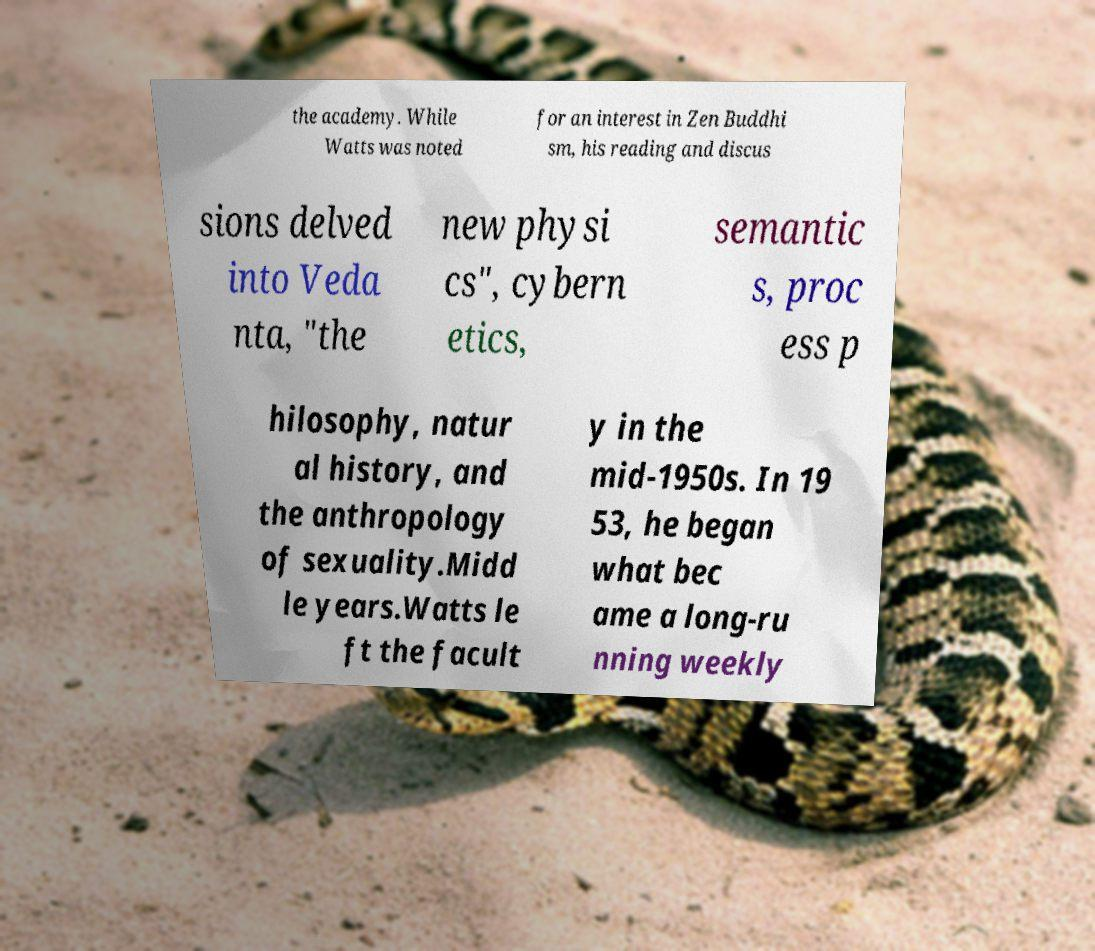Can you read and provide the text displayed in the image?This photo seems to have some interesting text. Can you extract and type it out for me? the academy. While Watts was noted for an interest in Zen Buddhi sm, his reading and discus sions delved into Veda nta, "the new physi cs", cybern etics, semantic s, proc ess p hilosophy, natur al history, and the anthropology of sexuality.Midd le years.Watts le ft the facult y in the mid-1950s. In 19 53, he began what bec ame a long-ru nning weekly 